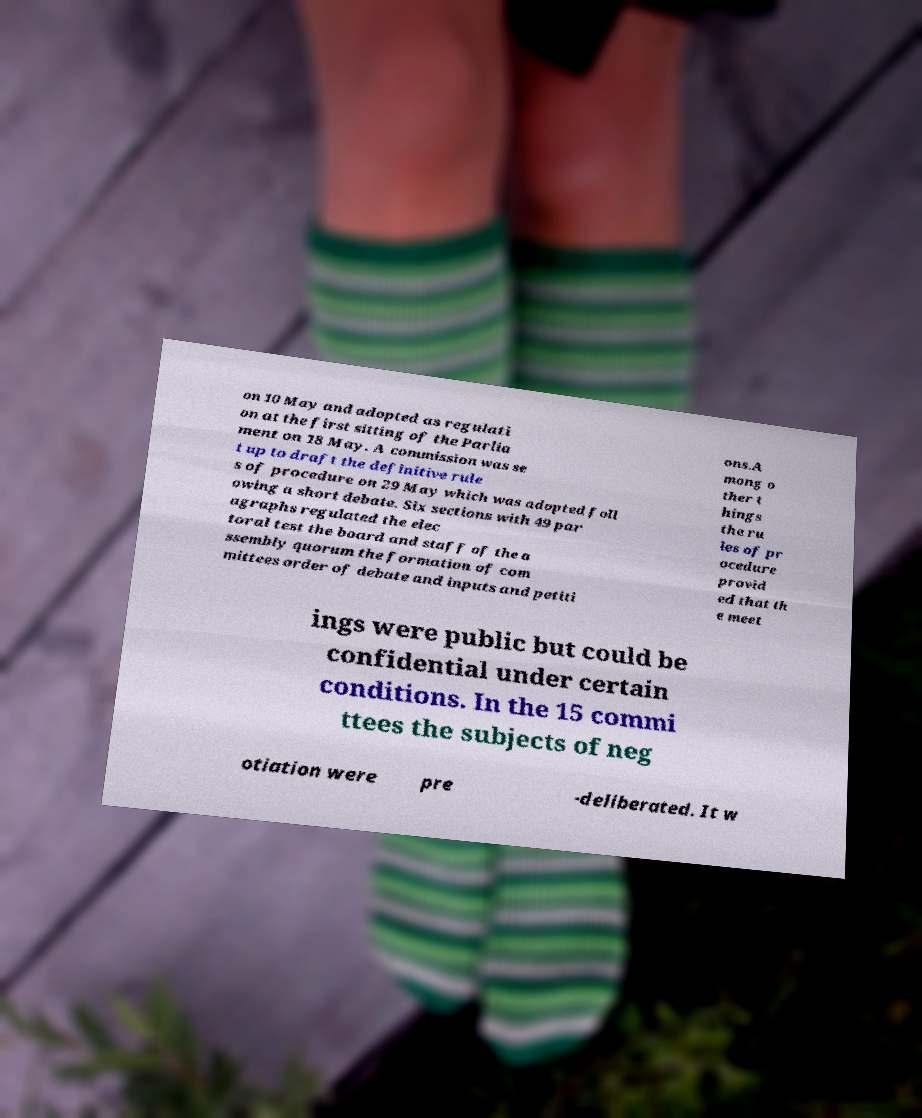Could you assist in decoding the text presented in this image and type it out clearly? on 10 May and adopted as regulati on at the first sitting of the Parlia ment on 18 May. A commission was se t up to draft the definitive rule s of procedure on 29 May which was adopted foll owing a short debate. Six sections with 49 par agraphs regulated the elec toral test the board and staff of the a ssembly quorum the formation of com mittees order of debate and inputs and petiti ons.A mong o ther t hings the ru les of pr ocedure provid ed that th e meet ings were public but could be confidential under certain conditions. In the 15 commi ttees the subjects of neg otiation were pre -deliberated. It w 